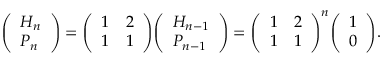Convert formula to latex. <formula><loc_0><loc_0><loc_500><loc_500>{ \left ( \begin{array} { l } { H _ { n } } \\ { P _ { n } } \end{array} \right ) } = { \left ( \begin{array} { l l } { 1 } & { 2 } \\ { 1 } & { 1 } \end{array} \right ) } { \left ( \begin{array} { l } { H _ { n - 1 } } \\ { P _ { n - 1 } } \end{array} \right ) } = { \left ( \begin{array} { l l } { 1 } & { 2 } \\ { 1 } & { 1 } \end{array} \right ) } ^ { n } { \left ( \begin{array} { l } { 1 } \\ { 0 } \end{array} \right ) } .</formula> 